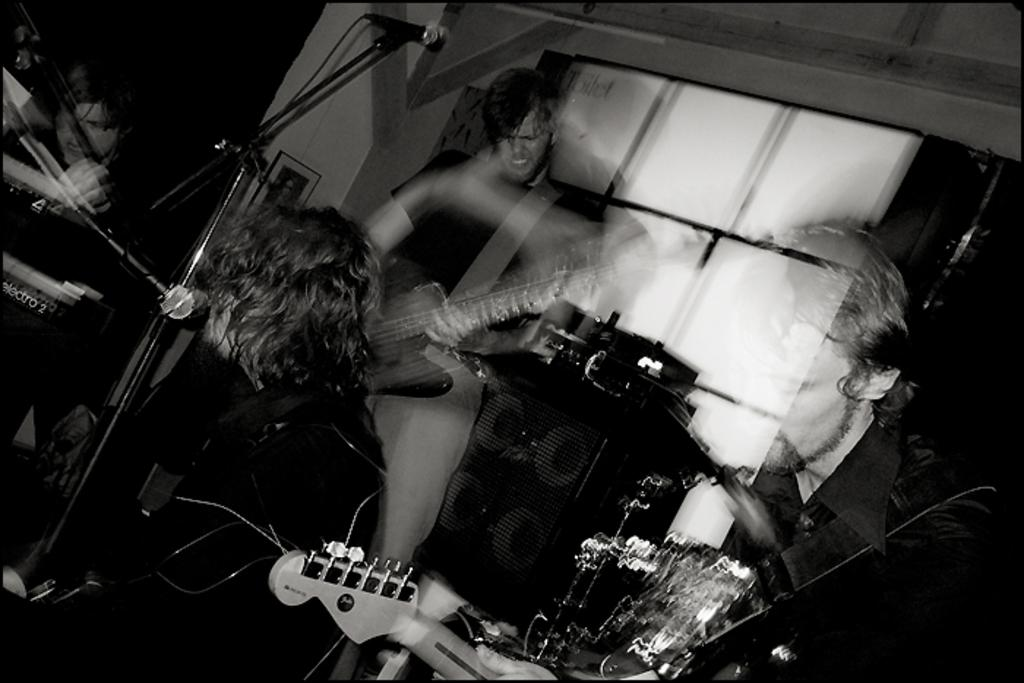How many people are in the image? There are four persons in the image. What are the persons doing in the image? The persons are playing guitar. What equipment is present in the image for amplifying sound? There are microphones and mic stands in the image. What can be seen in the background of the image? There is a window in the background of the image. What type of skin is visible on the guitar strings in the image? There is no skin visible on the guitar strings in the image; they are made of metal or nylon. What type of sticks are used to play the drums in the image? There are no drums or sticks present in the image; the persons are playing guitar. 